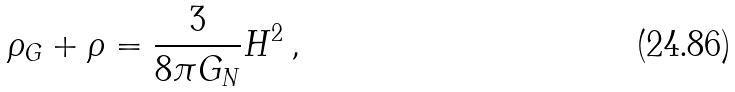Convert formula to latex. <formula><loc_0><loc_0><loc_500><loc_500>\rho _ { G } + \rho = \frac { 3 } { 8 \pi G _ { N } } H ^ { 2 } \, ,</formula> 